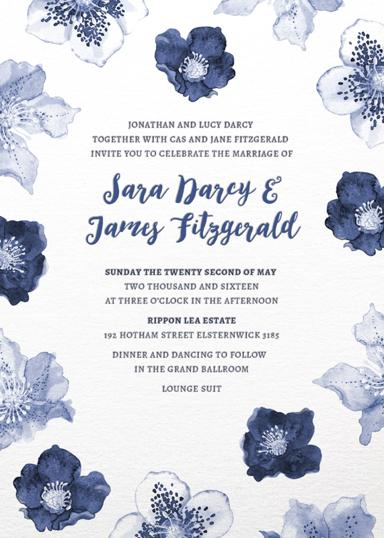Whose wedding is being celebrated in the invitation? The wedding invitation celebrates the union of Sara Darcy and James Fitzgerald. It's a special occasion marking the beginning of their lifelong journey together. 